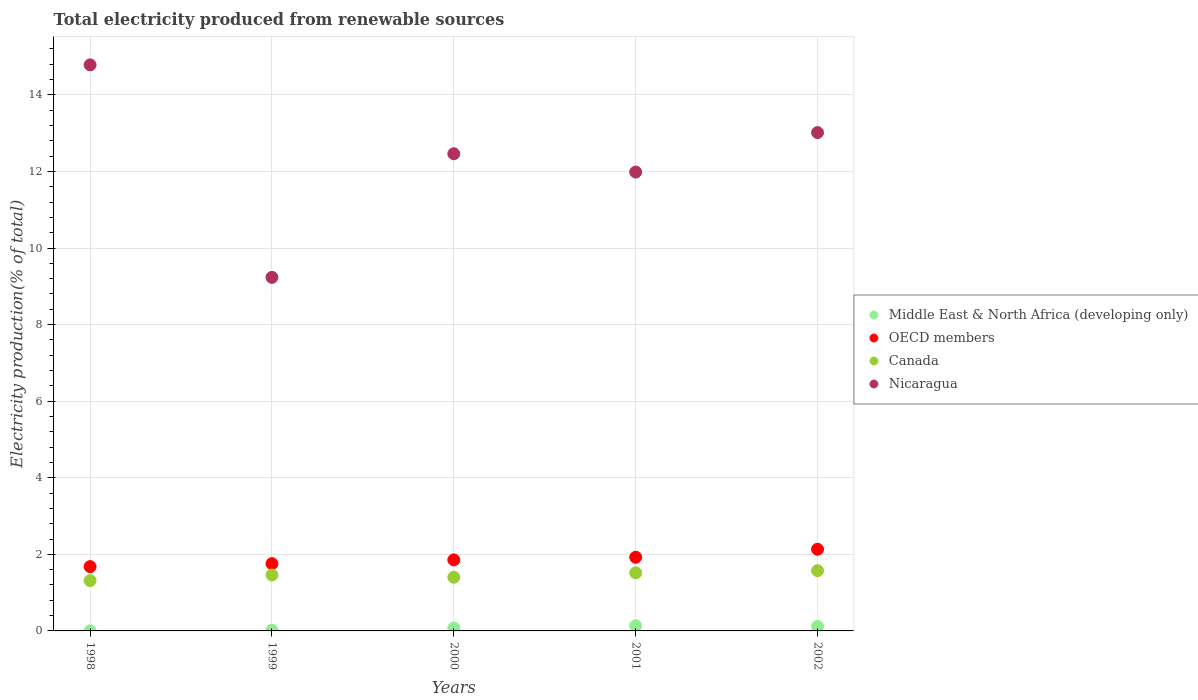How many different coloured dotlines are there?
Provide a succinct answer. 4. What is the total electricity produced in Nicaragua in 2000?
Provide a short and direct response. 12.46. Across all years, what is the maximum total electricity produced in OECD members?
Your answer should be very brief. 2.13. Across all years, what is the minimum total electricity produced in Nicaragua?
Provide a short and direct response. 9.23. In which year was the total electricity produced in Canada maximum?
Offer a terse response. 2002. In which year was the total electricity produced in Canada minimum?
Provide a short and direct response. 1998. What is the total total electricity produced in OECD members in the graph?
Offer a very short reply. 9.35. What is the difference between the total electricity produced in OECD members in 2000 and that in 2002?
Your response must be concise. -0.28. What is the difference between the total electricity produced in Middle East & North Africa (developing only) in 1999 and the total electricity produced in Canada in 2001?
Your answer should be very brief. -1.5. What is the average total electricity produced in Canada per year?
Offer a very short reply. 1.45. In the year 2002, what is the difference between the total electricity produced in Nicaragua and total electricity produced in OECD members?
Give a very brief answer. 10.88. What is the ratio of the total electricity produced in OECD members in 1998 to that in 2002?
Ensure brevity in your answer.  0.79. Is the total electricity produced in Nicaragua in 1998 less than that in 2000?
Make the answer very short. No. What is the difference between the highest and the second highest total electricity produced in OECD members?
Your answer should be compact. 0.21. What is the difference between the highest and the lowest total electricity produced in Middle East & North Africa (developing only)?
Your answer should be very brief. 0.13. Is the sum of the total electricity produced in OECD members in 1998 and 1999 greater than the maximum total electricity produced in Middle East & North Africa (developing only) across all years?
Make the answer very short. Yes. Is it the case that in every year, the sum of the total electricity produced in Middle East & North Africa (developing only) and total electricity produced in Canada  is greater than the sum of total electricity produced in OECD members and total electricity produced in Nicaragua?
Keep it short and to the point. No. Is it the case that in every year, the sum of the total electricity produced in OECD members and total electricity produced in Canada  is greater than the total electricity produced in Middle East & North Africa (developing only)?
Provide a succinct answer. Yes. Does the total electricity produced in Canada monotonically increase over the years?
Your response must be concise. No. Is the total electricity produced in Canada strictly greater than the total electricity produced in Nicaragua over the years?
Offer a very short reply. No. Is the total electricity produced in Canada strictly less than the total electricity produced in Middle East & North Africa (developing only) over the years?
Keep it short and to the point. No. Are the values on the major ticks of Y-axis written in scientific E-notation?
Offer a very short reply. No. Does the graph contain any zero values?
Give a very brief answer. No. Does the graph contain grids?
Your answer should be compact. Yes. How many legend labels are there?
Your answer should be very brief. 4. What is the title of the graph?
Your answer should be very brief. Total electricity produced from renewable sources. Does "Albania" appear as one of the legend labels in the graph?
Your answer should be very brief. No. What is the label or title of the X-axis?
Your answer should be compact. Years. What is the Electricity production(% of total) of Middle East & North Africa (developing only) in 1998?
Provide a short and direct response. 0. What is the Electricity production(% of total) of OECD members in 1998?
Make the answer very short. 1.68. What is the Electricity production(% of total) of Canada in 1998?
Your answer should be very brief. 1.31. What is the Electricity production(% of total) of Nicaragua in 1998?
Your answer should be compact. 14.78. What is the Electricity production(% of total) in Middle East & North Africa (developing only) in 1999?
Your answer should be very brief. 0.02. What is the Electricity production(% of total) in OECD members in 1999?
Keep it short and to the point. 1.76. What is the Electricity production(% of total) in Canada in 1999?
Provide a short and direct response. 1.46. What is the Electricity production(% of total) of Nicaragua in 1999?
Your response must be concise. 9.23. What is the Electricity production(% of total) in Middle East & North Africa (developing only) in 2000?
Offer a terse response. 0.08. What is the Electricity production(% of total) in OECD members in 2000?
Your response must be concise. 1.86. What is the Electricity production(% of total) of Canada in 2000?
Your answer should be compact. 1.4. What is the Electricity production(% of total) of Nicaragua in 2000?
Provide a short and direct response. 12.46. What is the Electricity production(% of total) of Middle East & North Africa (developing only) in 2001?
Provide a succinct answer. 0.13. What is the Electricity production(% of total) in OECD members in 2001?
Give a very brief answer. 1.92. What is the Electricity production(% of total) in Canada in 2001?
Provide a short and direct response. 1.52. What is the Electricity production(% of total) of Nicaragua in 2001?
Ensure brevity in your answer.  11.98. What is the Electricity production(% of total) in Middle East & North Africa (developing only) in 2002?
Provide a succinct answer. 0.12. What is the Electricity production(% of total) of OECD members in 2002?
Give a very brief answer. 2.13. What is the Electricity production(% of total) of Canada in 2002?
Your response must be concise. 1.57. What is the Electricity production(% of total) in Nicaragua in 2002?
Provide a succinct answer. 13.02. Across all years, what is the maximum Electricity production(% of total) in Middle East & North Africa (developing only)?
Provide a short and direct response. 0.13. Across all years, what is the maximum Electricity production(% of total) of OECD members?
Ensure brevity in your answer.  2.13. Across all years, what is the maximum Electricity production(% of total) in Canada?
Your answer should be compact. 1.57. Across all years, what is the maximum Electricity production(% of total) of Nicaragua?
Your answer should be very brief. 14.78. Across all years, what is the minimum Electricity production(% of total) in Middle East & North Africa (developing only)?
Provide a succinct answer. 0. Across all years, what is the minimum Electricity production(% of total) in OECD members?
Offer a terse response. 1.68. Across all years, what is the minimum Electricity production(% of total) of Canada?
Offer a terse response. 1.31. Across all years, what is the minimum Electricity production(% of total) in Nicaragua?
Provide a short and direct response. 9.23. What is the total Electricity production(% of total) in Middle East & North Africa (developing only) in the graph?
Your answer should be very brief. 0.35. What is the total Electricity production(% of total) in OECD members in the graph?
Make the answer very short. 9.35. What is the total Electricity production(% of total) of Canada in the graph?
Your response must be concise. 7.27. What is the total Electricity production(% of total) of Nicaragua in the graph?
Offer a terse response. 61.48. What is the difference between the Electricity production(% of total) in Middle East & North Africa (developing only) in 1998 and that in 1999?
Keep it short and to the point. -0.02. What is the difference between the Electricity production(% of total) in OECD members in 1998 and that in 1999?
Give a very brief answer. -0.08. What is the difference between the Electricity production(% of total) of Canada in 1998 and that in 1999?
Provide a succinct answer. -0.15. What is the difference between the Electricity production(% of total) in Nicaragua in 1998 and that in 1999?
Provide a short and direct response. 5.55. What is the difference between the Electricity production(% of total) in Middle East & North Africa (developing only) in 1998 and that in 2000?
Give a very brief answer. -0.08. What is the difference between the Electricity production(% of total) in OECD members in 1998 and that in 2000?
Keep it short and to the point. -0.18. What is the difference between the Electricity production(% of total) in Canada in 1998 and that in 2000?
Give a very brief answer. -0.09. What is the difference between the Electricity production(% of total) in Nicaragua in 1998 and that in 2000?
Offer a terse response. 2.32. What is the difference between the Electricity production(% of total) in Middle East & North Africa (developing only) in 1998 and that in 2001?
Keep it short and to the point. -0.13. What is the difference between the Electricity production(% of total) of OECD members in 1998 and that in 2001?
Your response must be concise. -0.24. What is the difference between the Electricity production(% of total) in Canada in 1998 and that in 2001?
Give a very brief answer. -0.2. What is the difference between the Electricity production(% of total) of Nicaragua in 1998 and that in 2001?
Your response must be concise. 2.8. What is the difference between the Electricity production(% of total) in Middle East & North Africa (developing only) in 1998 and that in 2002?
Ensure brevity in your answer.  -0.12. What is the difference between the Electricity production(% of total) of OECD members in 1998 and that in 2002?
Your answer should be compact. -0.45. What is the difference between the Electricity production(% of total) in Canada in 1998 and that in 2002?
Your answer should be compact. -0.26. What is the difference between the Electricity production(% of total) in Nicaragua in 1998 and that in 2002?
Your response must be concise. 1.77. What is the difference between the Electricity production(% of total) in Middle East & North Africa (developing only) in 1999 and that in 2000?
Your answer should be compact. -0.06. What is the difference between the Electricity production(% of total) in OECD members in 1999 and that in 2000?
Keep it short and to the point. -0.1. What is the difference between the Electricity production(% of total) of Canada in 1999 and that in 2000?
Your answer should be compact. 0.06. What is the difference between the Electricity production(% of total) of Nicaragua in 1999 and that in 2000?
Make the answer very short. -3.23. What is the difference between the Electricity production(% of total) of Middle East & North Africa (developing only) in 1999 and that in 2001?
Offer a terse response. -0.12. What is the difference between the Electricity production(% of total) in OECD members in 1999 and that in 2001?
Ensure brevity in your answer.  -0.17. What is the difference between the Electricity production(% of total) in Canada in 1999 and that in 2001?
Your response must be concise. -0.06. What is the difference between the Electricity production(% of total) of Nicaragua in 1999 and that in 2001?
Offer a very short reply. -2.75. What is the difference between the Electricity production(% of total) of Middle East & North Africa (developing only) in 1999 and that in 2002?
Keep it short and to the point. -0.1. What is the difference between the Electricity production(% of total) of OECD members in 1999 and that in 2002?
Provide a short and direct response. -0.38. What is the difference between the Electricity production(% of total) in Canada in 1999 and that in 2002?
Your response must be concise. -0.11. What is the difference between the Electricity production(% of total) in Nicaragua in 1999 and that in 2002?
Provide a short and direct response. -3.78. What is the difference between the Electricity production(% of total) of Middle East & North Africa (developing only) in 2000 and that in 2001?
Ensure brevity in your answer.  -0.06. What is the difference between the Electricity production(% of total) in OECD members in 2000 and that in 2001?
Your answer should be compact. -0.07. What is the difference between the Electricity production(% of total) of Canada in 2000 and that in 2001?
Keep it short and to the point. -0.12. What is the difference between the Electricity production(% of total) in Nicaragua in 2000 and that in 2001?
Ensure brevity in your answer.  0.48. What is the difference between the Electricity production(% of total) of Middle East & North Africa (developing only) in 2000 and that in 2002?
Your answer should be compact. -0.04. What is the difference between the Electricity production(% of total) in OECD members in 2000 and that in 2002?
Provide a short and direct response. -0.28. What is the difference between the Electricity production(% of total) of Canada in 2000 and that in 2002?
Your answer should be very brief. -0.17. What is the difference between the Electricity production(% of total) in Nicaragua in 2000 and that in 2002?
Give a very brief answer. -0.55. What is the difference between the Electricity production(% of total) of Middle East & North Africa (developing only) in 2001 and that in 2002?
Keep it short and to the point. 0.02. What is the difference between the Electricity production(% of total) in OECD members in 2001 and that in 2002?
Your answer should be compact. -0.21. What is the difference between the Electricity production(% of total) of Canada in 2001 and that in 2002?
Your response must be concise. -0.06. What is the difference between the Electricity production(% of total) in Nicaragua in 2001 and that in 2002?
Give a very brief answer. -1.03. What is the difference between the Electricity production(% of total) of Middle East & North Africa (developing only) in 1998 and the Electricity production(% of total) of OECD members in 1999?
Your answer should be very brief. -1.76. What is the difference between the Electricity production(% of total) of Middle East & North Africa (developing only) in 1998 and the Electricity production(% of total) of Canada in 1999?
Give a very brief answer. -1.46. What is the difference between the Electricity production(% of total) of Middle East & North Africa (developing only) in 1998 and the Electricity production(% of total) of Nicaragua in 1999?
Provide a succinct answer. -9.23. What is the difference between the Electricity production(% of total) of OECD members in 1998 and the Electricity production(% of total) of Canada in 1999?
Your answer should be very brief. 0.22. What is the difference between the Electricity production(% of total) in OECD members in 1998 and the Electricity production(% of total) in Nicaragua in 1999?
Give a very brief answer. -7.55. What is the difference between the Electricity production(% of total) of Canada in 1998 and the Electricity production(% of total) of Nicaragua in 1999?
Provide a short and direct response. -7.92. What is the difference between the Electricity production(% of total) in Middle East & North Africa (developing only) in 1998 and the Electricity production(% of total) in OECD members in 2000?
Your answer should be very brief. -1.85. What is the difference between the Electricity production(% of total) of Middle East & North Africa (developing only) in 1998 and the Electricity production(% of total) of Canada in 2000?
Keep it short and to the point. -1.4. What is the difference between the Electricity production(% of total) in Middle East & North Africa (developing only) in 1998 and the Electricity production(% of total) in Nicaragua in 2000?
Provide a short and direct response. -12.46. What is the difference between the Electricity production(% of total) of OECD members in 1998 and the Electricity production(% of total) of Canada in 2000?
Provide a succinct answer. 0.28. What is the difference between the Electricity production(% of total) of OECD members in 1998 and the Electricity production(% of total) of Nicaragua in 2000?
Offer a very short reply. -10.78. What is the difference between the Electricity production(% of total) in Canada in 1998 and the Electricity production(% of total) in Nicaragua in 2000?
Your response must be concise. -11.15. What is the difference between the Electricity production(% of total) of Middle East & North Africa (developing only) in 1998 and the Electricity production(% of total) of OECD members in 2001?
Offer a very short reply. -1.92. What is the difference between the Electricity production(% of total) in Middle East & North Africa (developing only) in 1998 and the Electricity production(% of total) in Canada in 2001?
Your answer should be very brief. -1.52. What is the difference between the Electricity production(% of total) of Middle East & North Africa (developing only) in 1998 and the Electricity production(% of total) of Nicaragua in 2001?
Keep it short and to the point. -11.98. What is the difference between the Electricity production(% of total) in OECD members in 1998 and the Electricity production(% of total) in Canada in 2001?
Ensure brevity in your answer.  0.16. What is the difference between the Electricity production(% of total) in OECD members in 1998 and the Electricity production(% of total) in Nicaragua in 2001?
Make the answer very short. -10.3. What is the difference between the Electricity production(% of total) in Canada in 1998 and the Electricity production(% of total) in Nicaragua in 2001?
Your answer should be compact. -10.67. What is the difference between the Electricity production(% of total) of Middle East & North Africa (developing only) in 1998 and the Electricity production(% of total) of OECD members in 2002?
Provide a succinct answer. -2.13. What is the difference between the Electricity production(% of total) of Middle East & North Africa (developing only) in 1998 and the Electricity production(% of total) of Canada in 2002?
Keep it short and to the point. -1.57. What is the difference between the Electricity production(% of total) of Middle East & North Africa (developing only) in 1998 and the Electricity production(% of total) of Nicaragua in 2002?
Ensure brevity in your answer.  -13.01. What is the difference between the Electricity production(% of total) in OECD members in 1998 and the Electricity production(% of total) in Canada in 2002?
Keep it short and to the point. 0.11. What is the difference between the Electricity production(% of total) of OECD members in 1998 and the Electricity production(% of total) of Nicaragua in 2002?
Make the answer very short. -11.34. What is the difference between the Electricity production(% of total) in Canada in 1998 and the Electricity production(% of total) in Nicaragua in 2002?
Make the answer very short. -11.7. What is the difference between the Electricity production(% of total) in Middle East & North Africa (developing only) in 1999 and the Electricity production(% of total) in OECD members in 2000?
Provide a succinct answer. -1.84. What is the difference between the Electricity production(% of total) of Middle East & North Africa (developing only) in 1999 and the Electricity production(% of total) of Canada in 2000?
Your answer should be very brief. -1.38. What is the difference between the Electricity production(% of total) of Middle East & North Africa (developing only) in 1999 and the Electricity production(% of total) of Nicaragua in 2000?
Provide a succinct answer. -12.44. What is the difference between the Electricity production(% of total) in OECD members in 1999 and the Electricity production(% of total) in Canada in 2000?
Keep it short and to the point. 0.36. What is the difference between the Electricity production(% of total) of OECD members in 1999 and the Electricity production(% of total) of Nicaragua in 2000?
Provide a short and direct response. -10.71. What is the difference between the Electricity production(% of total) in Canada in 1999 and the Electricity production(% of total) in Nicaragua in 2000?
Offer a very short reply. -11. What is the difference between the Electricity production(% of total) of Middle East & North Africa (developing only) in 1999 and the Electricity production(% of total) of OECD members in 2001?
Give a very brief answer. -1.9. What is the difference between the Electricity production(% of total) of Middle East & North Africa (developing only) in 1999 and the Electricity production(% of total) of Canada in 2001?
Your answer should be very brief. -1.5. What is the difference between the Electricity production(% of total) in Middle East & North Africa (developing only) in 1999 and the Electricity production(% of total) in Nicaragua in 2001?
Ensure brevity in your answer.  -11.96. What is the difference between the Electricity production(% of total) of OECD members in 1999 and the Electricity production(% of total) of Canada in 2001?
Provide a succinct answer. 0.24. What is the difference between the Electricity production(% of total) in OECD members in 1999 and the Electricity production(% of total) in Nicaragua in 2001?
Offer a terse response. -10.23. What is the difference between the Electricity production(% of total) in Canada in 1999 and the Electricity production(% of total) in Nicaragua in 2001?
Your response must be concise. -10.52. What is the difference between the Electricity production(% of total) of Middle East & North Africa (developing only) in 1999 and the Electricity production(% of total) of OECD members in 2002?
Your answer should be very brief. -2.11. What is the difference between the Electricity production(% of total) of Middle East & North Africa (developing only) in 1999 and the Electricity production(% of total) of Canada in 2002?
Provide a short and direct response. -1.55. What is the difference between the Electricity production(% of total) of Middle East & North Africa (developing only) in 1999 and the Electricity production(% of total) of Nicaragua in 2002?
Keep it short and to the point. -13. What is the difference between the Electricity production(% of total) of OECD members in 1999 and the Electricity production(% of total) of Canada in 2002?
Offer a terse response. 0.18. What is the difference between the Electricity production(% of total) of OECD members in 1999 and the Electricity production(% of total) of Nicaragua in 2002?
Provide a succinct answer. -11.26. What is the difference between the Electricity production(% of total) of Canada in 1999 and the Electricity production(% of total) of Nicaragua in 2002?
Provide a succinct answer. -11.55. What is the difference between the Electricity production(% of total) in Middle East & North Africa (developing only) in 2000 and the Electricity production(% of total) in OECD members in 2001?
Ensure brevity in your answer.  -1.85. What is the difference between the Electricity production(% of total) in Middle East & North Africa (developing only) in 2000 and the Electricity production(% of total) in Canada in 2001?
Make the answer very short. -1.44. What is the difference between the Electricity production(% of total) in Middle East & North Africa (developing only) in 2000 and the Electricity production(% of total) in Nicaragua in 2001?
Provide a succinct answer. -11.91. What is the difference between the Electricity production(% of total) of OECD members in 2000 and the Electricity production(% of total) of Canada in 2001?
Keep it short and to the point. 0.34. What is the difference between the Electricity production(% of total) in OECD members in 2000 and the Electricity production(% of total) in Nicaragua in 2001?
Your answer should be compact. -10.13. What is the difference between the Electricity production(% of total) of Canada in 2000 and the Electricity production(% of total) of Nicaragua in 2001?
Give a very brief answer. -10.58. What is the difference between the Electricity production(% of total) of Middle East & North Africa (developing only) in 2000 and the Electricity production(% of total) of OECD members in 2002?
Give a very brief answer. -2.06. What is the difference between the Electricity production(% of total) of Middle East & North Africa (developing only) in 2000 and the Electricity production(% of total) of Canada in 2002?
Offer a terse response. -1.5. What is the difference between the Electricity production(% of total) of Middle East & North Africa (developing only) in 2000 and the Electricity production(% of total) of Nicaragua in 2002?
Give a very brief answer. -12.94. What is the difference between the Electricity production(% of total) of OECD members in 2000 and the Electricity production(% of total) of Canada in 2002?
Your answer should be very brief. 0.28. What is the difference between the Electricity production(% of total) of OECD members in 2000 and the Electricity production(% of total) of Nicaragua in 2002?
Give a very brief answer. -11.16. What is the difference between the Electricity production(% of total) of Canada in 2000 and the Electricity production(% of total) of Nicaragua in 2002?
Your answer should be very brief. -11.61. What is the difference between the Electricity production(% of total) of Middle East & North Africa (developing only) in 2001 and the Electricity production(% of total) of OECD members in 2002?
Keep it short and to the point. -2. What is the difference between the Electricity production(% of total) of Middle East & North Africa (developing only) in 2001 and the Electricity production(% of total) of Canada in 2002?
Provide a succinct answer. -1.44. What is the difference between the Electricity production(% of total) of Middle East & North Africa (developing only) in 2001 and the Electricity production(% of total) of Nicaragua in 2002?
Provide a short and direct response. -12.88. What is the difference between the Electricity production(% of total) in OECD members in 2001 and the Electricity production(% of total) in Canada in 2002?
Ensure brevity in your answer.  0.35. What is the difference between the Electricity production(% of total) in OECD members in 2001 and the Electricity production(% of total) in Nicaragua in 2002?
Your response must be concise. -11.09. What is the difference between the Electricity production(% of total) of Canada in 2001 and the Electricity production(% of total) of Nicaragua in 2002?
Make the answer very short. -11.5. What is the average Electricity production(% of total) in Middle East & North Africa (developing only) per year?
Provide a short and direct response. 0.07. What is the average Electricity production(% of total) in OECD members per year?
Offer a terse response. 1.87. What is the average Electricity production(% of total) of Canada per year?
Your response must be concise. 1.45. What is the average Electricity production(% of total) in Nicaragua per year?
Give a very brief answer. 12.3. In the year 1998, what is the difference between the Electricity production(% of total) in Middle East & North Africa (developing only) and Electricity production(% of total) in OECD members?
Give a very brief answer. -1.68. In the year 1998, what is the difference between the Electricity production(% of total) of Middle East & North Africa (developing only) and Electricity production(% of total) of Canada?
Your response must be concise. -1.31. In the year 1998, what is the difference between the Electricity production(% of total) in Middle East & North Africa (developing only) and Electricity production(% of total) in Nicaragua?
Offer a terse response. -14.78. In the year 1998, what is the difference between the Electricity production(% of total) of OECD members and Electricity production(% of total) of Canada?
Give a very brief answer. 0.37. In the year 1998, what is the difference between the Electricity production(% of total) in OECD members and Electricity production(% of total) in Nicaragua?
Provide a succinct answer. -13.1. In the year 1998, what is the difference between the Electricity production(% of total) in Canada and Electricity production(% of total) in Nicaragua?
Provide a short and direct response. -13.47. In the year 1999, what is the difference between the Electricity production(% of total) of Middle East & North Africa (developing only) and Electricity production(% of total) of OECD members?
Offer a terse response. -1.74. In the year 1999, what is the difference between the Electricity production(% of total) in Middle East & North Africa (developing only) and Electricity production(% of total) in Canada?
Provide a short and direct response. -1.44. In the year 1999, what is the difference between the Electricity production(% of total) in Middle East & North Africa (developing only) and Electricity production(% of total) in Nicaragua?
Give a very brief answer. -9.21. In the year 1999, what is the difference between the Electricity production(% of total) in OECD members and Electricity production(% of total) in Canada?
Your response must be concise. 0.3. In the year 1999, what is the difference between the Electricity production(% of total) in OECD members and Electricity production(% of total) in Nicaragua?
Keep it short and to the point. -7.48. In the year 1999, what is the difference between the Electricity production(% of total) of Canada and Electricity production(% of total) of Nicaragua?
Provide a short and direct response. -7.77. In the year 2000, what is the difference between the Electricity production(% of total) in Middle East & North Africa (developing only) and Electricity production(% of total) in OECD members?
Make the answer very short. -1.78. In the year 2000, what is the difference between the Electricity production(% of total) of Middle East & North Africa (developing only) and Electricity production(% of total) of Canada?
Offer a very short reply. -1.32. In the year 2000, what is the difference between the Electricity production(% of total) in Middle East & North Africa (developing only) and Electricity production(% of total) in Nicaragua?
Ensure brevity in your answer.  -12.39. In the year 2000, what is the difference between the Electricity production(% of total) of OECD members and Electricity production(% of total) of Canada?
Your answer should be compact. 0.45. In the year 2000, what is the difference between the Electricity production(% of total) in OECD members and Electricity production(% of total) in Nicaragua?
Your answer should be compact. -10.61. In the year 2000, what is the difference between the Electricity production(% of total) in Canada and Electricity production(% of total) in Nicaragua?
Give a very brief answer. -11.06. In the year 2001, what is the difference between the Electricity production(% of total) of Middle East & North Africa (developing only) and Electricity production(% of total) of OECD members?
Provide a short and direct response. -1.79. In the year 2001, what is the difference between the Electricity production(% of total) of Middle East & North Africa (developing only) and Electricity production(% of total) of Canada?
Make the answer very short. -1.38. In the year 2001, what is the difference between the Electricity production(% of total) of Middle East & North Africa (developing only) and Electricity production(% of total) of Nicaragua?
Ensure brevity in your answer.  -11.85. In the year 2001, what is the difference between the Electricity production(% of total) in OECD members and Electricity production(% of total) in Canada?
Give a very brief answer. 0.41. In the year 2001, what is the difference between the Electricity production(% of total) of OECD members and Electricity production(% of total) of Nicaragua?
Provide a succinct answer. -10.06. In the year 2001, what is the difference between the Electricity production(% of total) of Canada and Electricity production(% of total) of Nicaragua?
Keep it short and to the point. -10.47. In the year 2002, what is the difference between the Electricity production(% of total) of Middle East & North Africa (developing only) and Electricity production(% of total) of OECD members?
Ensure brevity in your answer.  -2.01. In the year 2002, what is the difference between the Electricity production(% of total) of Middle East & North Africa (developing only) and Electricity production(% of total) of Canada?
Your answer should be very brief. -1.45. In the year 2002, what is the difference between the Electricity production(% of total) in Middle East & North Africa (developing only) and Electricity production(% of total) in Nicaragua?
Offer a terse response. -12.9. In the year 2002, what is the difference between the Electricity production(% of total) in OECD members and Electricity production(% of total) in Canada?
Make the answer very short. 0.56. In the year 2002, what is the difference between the Electricity production(% of total) in OECD members and Electricity production(% of total) in Nicaragua?
Make the answer very short. -10.88. In the year 2002, what is the difference between the Electricity production(% of total) in Canada and Electricity production(% of total) in Nicaragua?
Your response must be concise. -11.44. What is the ratio of the Electricity production(% of total) of Middle East & North Africa (developing only) in 1998 to that in 1999?
Your answer should be very brief. 0.05. What is the ratio of the Electricity production(% of total) of OECD members in 1998 to that in 1999?
Provide a succinct answer. 0.96. What is the ratio of the Electricity production(% of total) of Canada in 1998 to that in 1999?
Provide a short and direct response. 0.9. What is the ratio of the Electricity production(% of total) in Nicaragua in 1998 to that in 1999?
Offer a very short reply. 1.6. What is the ratio of the Electricity production(% of total) in Middle East & North Africa (developing only) in 1998 to that in 2000?
Provide a succinct answer. 0.01. What is the ratio of the Electricity production(% of total) of OECD members in 1998 to that in 2000?
Provide a short and direct response. 0.91. What is the ratio of the Electricity production(% of total) in Canada in 1998 to that in 2000?
Your answer should be compact. 0.94. What is the ratio of the Electricity production(% of total) in Nicaragua in 1998 to that in 2000?
Give a very brief answer. 1.19. What is the ratio of the Electricity production(% of total) in Middle East & North Africa (developing only) in 1998 to that in 2001?
Give a very brief answer. 0.01. What is the ratio of the Electricity production(% of total) of OECD members in 1998 to that in 2001?
Your answer should be compact. 0.87. What is the ratio of the Electricity production(% of total) in Canada in 1998 to that in 2001?
Keep it short and to the point. 0.87. What is the ratio of the Electricity production(% of total) of Nicaragua in 1998 to that in 2001?
Give a very brief answer. 1.23. What is the ratio of the Electricity production(% of total) of Middle East & North Africa (developing only) in 1998 to that in 2002?
Your response must be concise. 0.01. What is the ratio of the Electricity production(% of total) of OECD members in 1998 to that in 2002?
Your answer should be compact. 0.79. What is the ratio of the Electricity production(% of total) of Canada in 1998 to that in 2002?
Give a very brief answer. 0.84. What is the ratio of the Electricity production(% of total) of Nicaragua in 1998 to that in 2002?
Give a very brief answer. 1.14. What is the ratio of the Electricity production(% of total) of Middle East & North Africa (developing only) in 1999 to that in 2000?
Offer a terse response. 0.25. What is the ratio of the Electricity production(% of total) of OECD members in 1999 to that in 2000?
Keep it short and to the point. 0.95. What is the ratio of the Electricity production(% of total) of Canada in 1999 to that in 2000?
Give a very brief answer. 1.04. What is the ratio of the Electricity production(% of total) of Nicaragua in 1999 to that in 2000?
Give a very brief answer. 0.74. What is the ratio of the Electricity production(% of total) of Middle East & North Africa (developing only) in 1999 to that in 2001?
Make the answer very short. 0.14. What is the ratio of the Electricity production(% of total) of OECD members in 1999 to that in 2001?
Your response must be concise. 0.91. What is the ratio of the Electricity production(% of total) in Nicaragua in 1999 to that in 2001?
Keep it short and to the point. 0.77. What is the ratio of the Electricity production(% of total) of Middle East & North Africa (developing only) in 1999 to that in 2002?
Provide a short and direct response. 0.16. What is the ratio of the Electricity production(% of total) in OECD members in 1999 to that in 2002?
Your answer should be very brief. 0.82. What is the ratio of the Electricity production(% of total) of Canada in 1999 to that in 2002?
Provide a succinct answer. 0.93. What is the ratio of the Electricity production(% of total) of Nicaragua in 1999 to that in 2002?
Your response must be concise. 0.71. What is the ratio of the Electricity production(% of total) in Middle East & North Africa (developing only) in 2000 to that in 2001?
Give a very brief answer. 0.57. What is the ratio of the Electricity production(% of total) of OECD members in 2000 to that in 2001?
Provide a short and direct response. 0.96. What is the ratio of the Electricity production(% of total) of Canada in 2000 to that in 2001?
Ensure brevity in your answer.  0.92. What is the ratio of the Electricity production(% of total) in Nicaragua in 2000 to that in 2001?
Make the answer very short. 1.04. What is the ratio of the Electricity production(% of total) in Middle East & North Africa (developing only) in 2000 to that in 2002?
Offer a terse response. 0.64. What is the ratio of the Electricity production(% of total) in OECD members in 2000 to that in 2002?
Your answer should be compact. 0.87. What is the ratio of the Electricity production(% of total) of Canada in 2000 to that in 2002?
Offer a very short reply. 0.89. What is the ratio of the Electricity production(% of total) in Nicaragua in 2000 to that in 2002?
Make the answer very short. 0.96. What is the ratio of the Electricity production(% of total) in Middle East & North Africa (developing only) in 2001 to that in 2002?
Offer a terse response. 1.13. What is the ratio of the Electricity production(% of total) in OECD members in 2001 to that in 2002?
Make the answer very short. 0.9. What is the ratio of the Electricity production(% of total) of Canada in 2001 to that in 2002?
Provide a succinct answer. 0.96. What is the ratio of the Electricity production(% of total) in Nicaragua in 2001 to that in 2002?
Your answer should be compact. 0.92. What is the difference between the highest and the second highest Electricity production(% of total) in Middle East & North Africa (developing only)?
Ensure brevity in your answer.  0.02. What is the difference between the highest and the second highest Electricity production(% of total) in OECD members?
Keep it short and to the point. 0.21. What is the difference between the highest and the second highest Electricity production(% of total) of Canada?
Provide a short and direct response. 0.06. What is the difference between the highest and the second highest Electricity production(% of total) in Nicaragua?
Your answer should be very brief. 1.77. What is the difference between the highest and the lowest Electricity production(% of total) in Middle East & North Africa (developing only)?
Your answer should be very brief. 0.13. What is the difference between the highest and the lowest Electricity production(% of total) of OECD members?
Provide a short and direct response. 0.45. What is the difference between the highest and the lowest Electricity production(% of total) of Canada?
Provide a short and direct response. 0.26. What is the difference between the highest and the lowest Electricity production(% of total) in Nicaragua?
Your response must be concise. 5.55. 